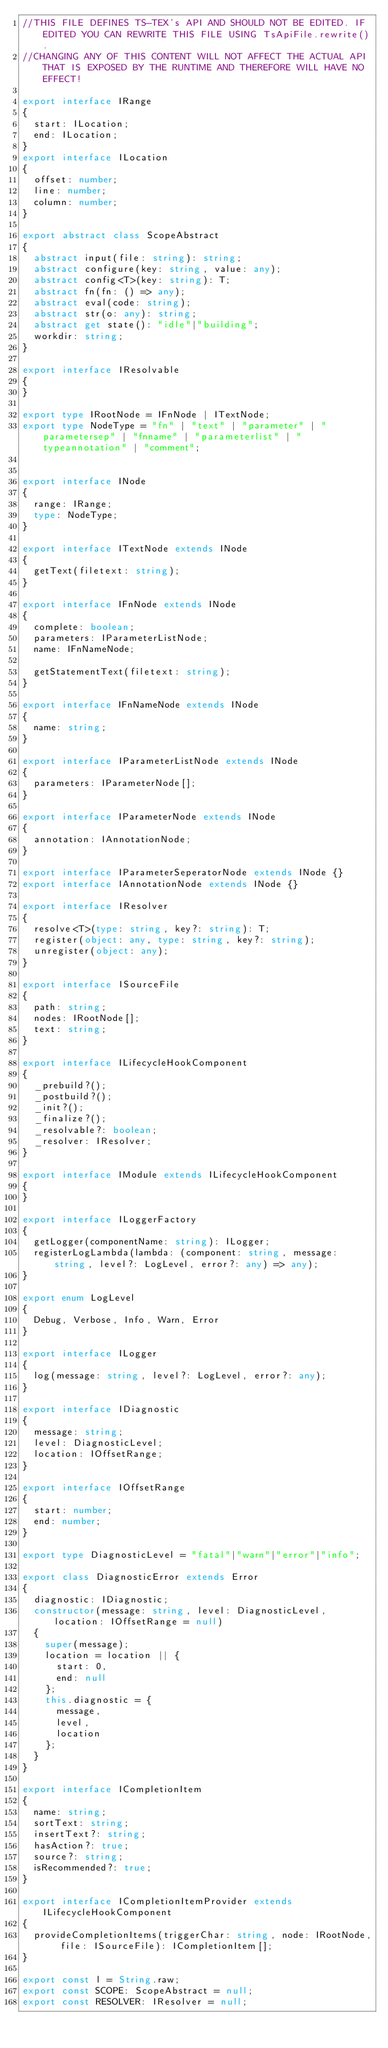<code> <loc_0><loc_0><loc_500><loc_500><_TypeScript_>//THIS FILE DEFINES TS-TEX's API AND SHOULD NOT BE EDITED. IF EDITED YOU CAN REWRITE THIS FILE USING TsApiFile.rewrite().
//CHANGING ANY OF THIS CONTENT WILL NOT AFFECT THE ACTUAL API THAT IS EXPOSED BY THE RUNTIME AND THEREFORE WILL HAVE NO EFFECT!

export interface IRange 
{
  start: ILocation;
  end: ILocation;
}
export interface ILocation
{
  offset: number;
  line: number;
  column: number;
}

export abstract class ScopeAbstract
{
  abstract input(file: string): string;
  abstract configure(key: string, value: any);
  abstract config<T>(key: string): T;
  abstract fn(fn: () => any);
  abstract eval(code: string);
  abstract str(o: any): string;
  abstract get state(): "idle"|"building";
  workdir: string;
}

export interface IResolvable
{
}

export type IRootNode = IFnNode | ITextNode;
export type NodeType = "fn" | "text" | "parameter" | "parametersep" | "fnname" | "parameterlist" | "typeannotation" | "comment";


export interface INode
{
  range: IRange;
  type: NodeType;
}

export interface ITextNode extends INode
{
  getText(filetext: string);
}

export interface IFnNode extends INode
{
  complete: boolean;
  parameters: IParameterListNode;
  name: IFnNameNode;

  getStatementText(filetext: string);
}

export interface IFnNameNode extends INode
{
  name: string;
}

export interface IParameterListNode extends INode
{
  parameters: IParameterNode[];
}

export interface IParameterNode extends INode
{
  annotation: IAnnotationNode;
}

export interface IParameterSeperatorNode extends INode {}
export interface IAnnotationNode extends INode {}

export interface IResolver
{
  resolve<T>(type: string, key?: string): T;
  register(object: any, type: string, key?: string);
  unregister(object: any);
}

export interface ISourceFile
{
  path: string;
  nodes: IRootNode[];
  text: string;
}

export interface ILifecycleHookComponent
{
  _prebuild?();
  _postbuild?();
  _init?();
  _finalize?();
  _resolvable?: boolean;
  _resolver: IResolver;
}

export interface IModule extends ILifecycleHookComponent
{
}

export interface ILoggerFactory
{
  getLogger(componentName: string): ILogger;
  registerLogLambda(lambda: (component: string, message: string, level?: LogLevel, error?: any) => any);
}

export enum LogLevel
{
  Debug, Verbose, Info, Warn, Error
}

export interface ILogger
{
  log(message: string, level?: LogLevel, error?: any);
}

export interface IDiagnostic
{
  message: string;
  level: DiagnosticLevel;
  location: IOffsetRange;
}

export interface IOffsetRange
{
  start: number;
  end: number;
}

export type DiagnosticLevel = "fatal"|"warn"|"error"|"info";

export class DiagnosticError extends Error
{
  diagnostic: IDiagnostic;
  constructor(message: string, level: DiagnosticLevel, location: IOffsetRange = null)
  {
    super(message);
    location = location || {
      start: 0,
      end: null
    };
    this.diagnostic = {
      message,
      level,
      location
    };
  }
}

export interface ICompletionItem
{
  name: string;
  sortText: string;
  insertText?: string;
  hasAction?: true;
  source?: string;
  isRecommended?: true;
}

export interface ICompletionItemProvider extends ILifecycleHookComponent
{
  provideCompletionItems(triggerChar: string, node: IRootNode, file: ISourceFile): ICompletionItem[];
}

export const l = String.raw;
export const SCOPE: ScopeAbstract = null;
export const RESOLVER: IResolver = null;
</code> 